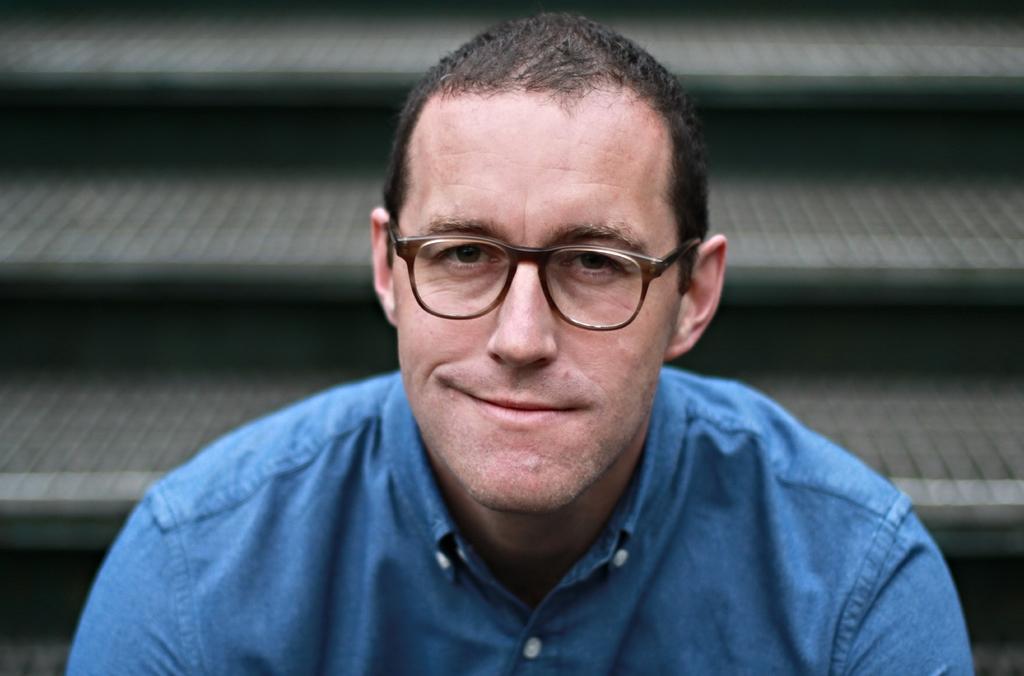How would you summarize this image in a sentence or two? In this image we can see a man and he wore spectacles. In the background we can see steps. 